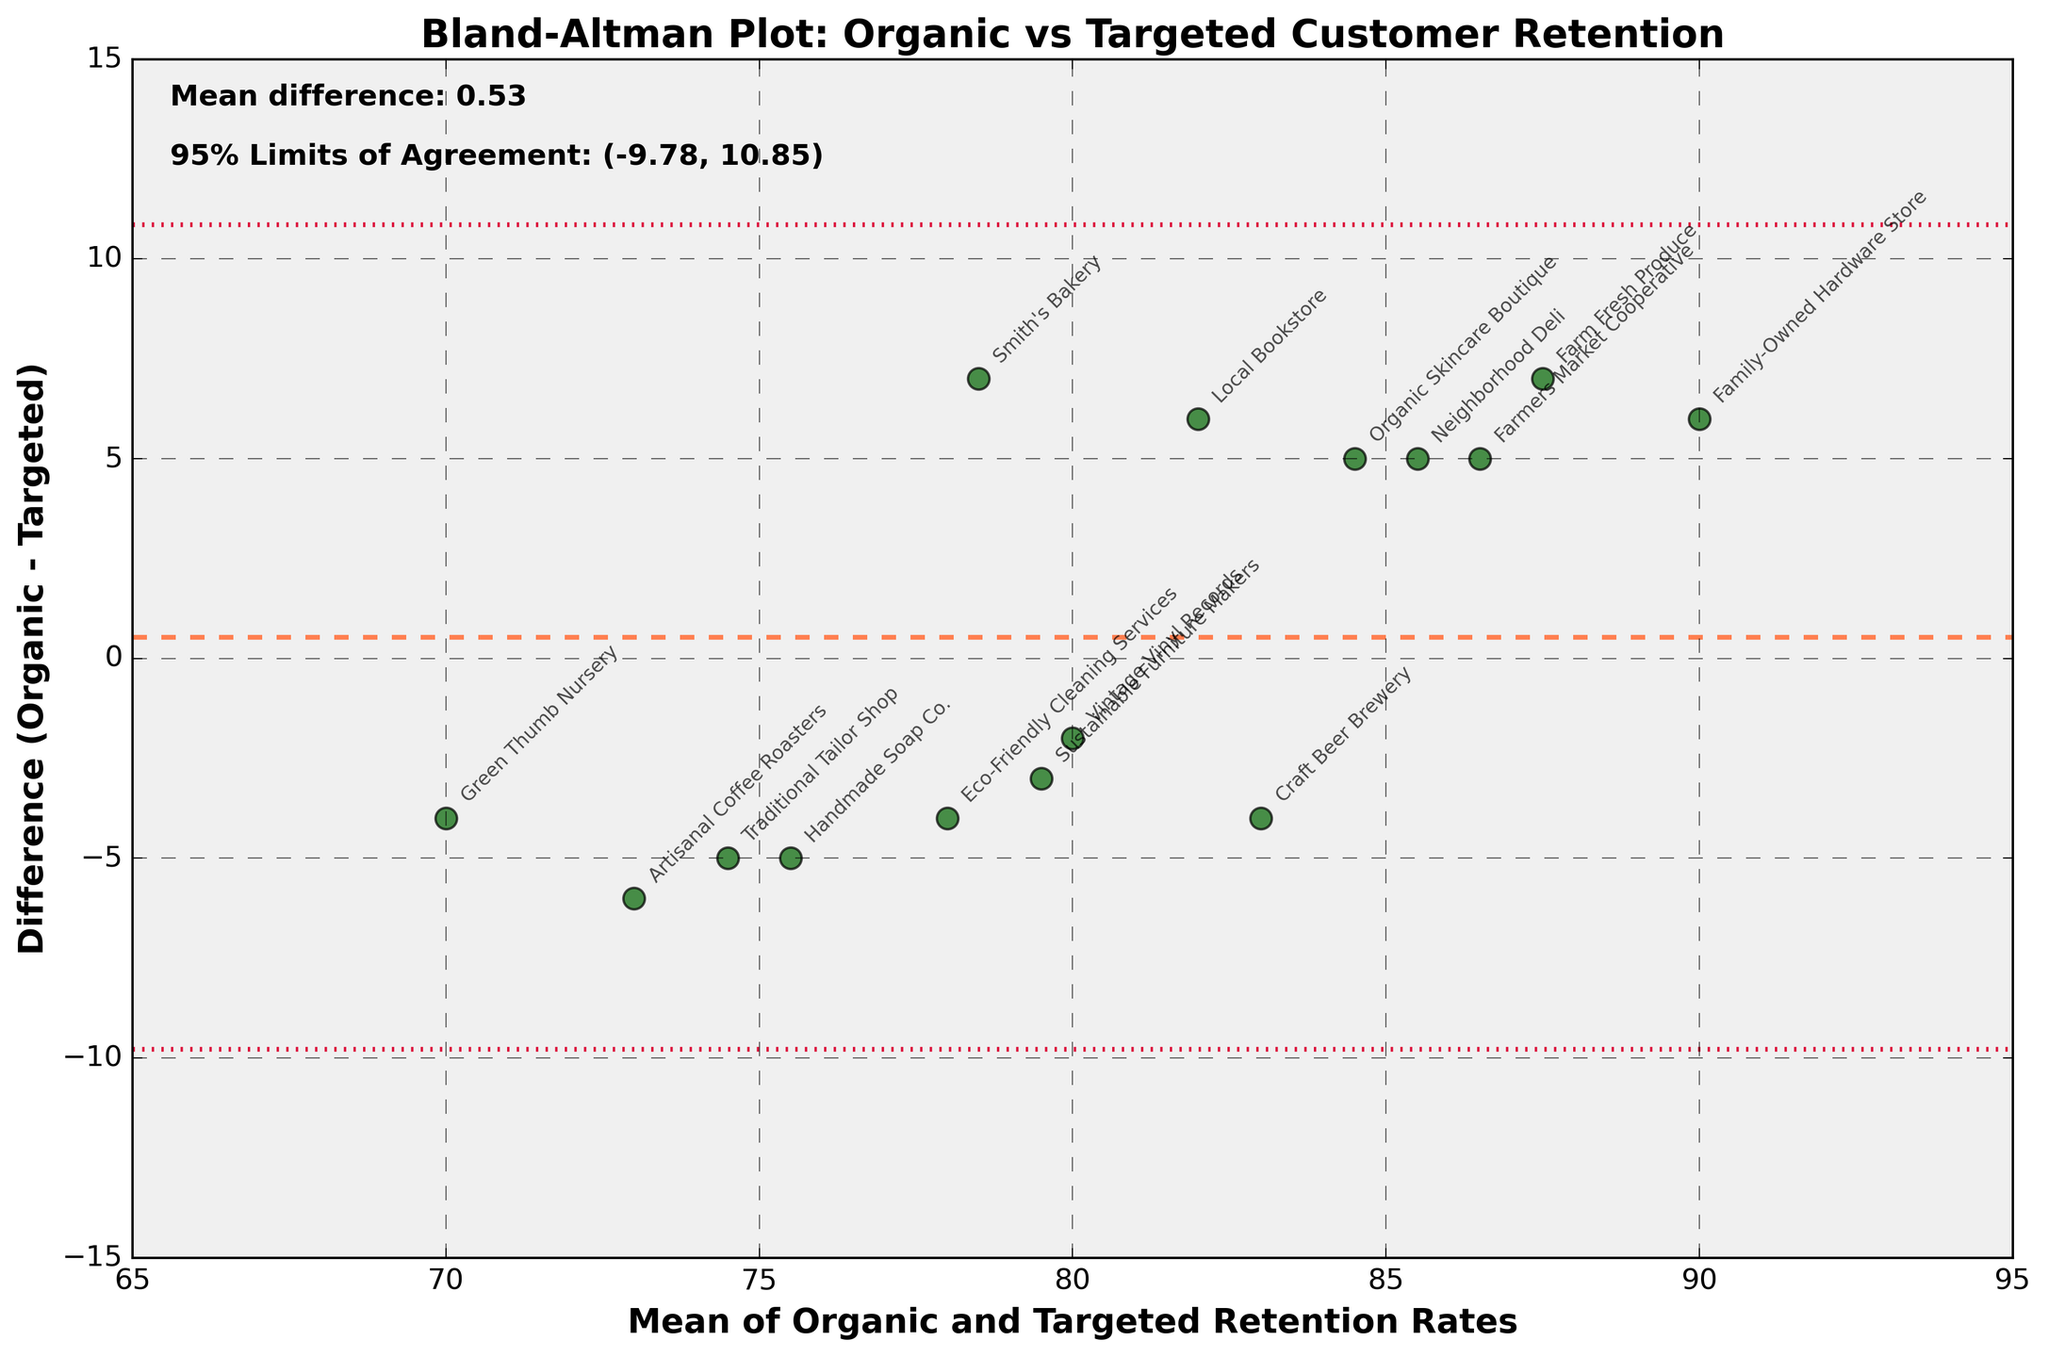What's the title of the figure? The title of the figure is displayed at the top center part of the plot. This is easy to identify as it is in a larger and bold font compared to the other text.
Answer: Bland-Altman Plot: Organic vs Targeted Customer Retention How many businesses are represented in the figure? The number of businesses can be determined by counting the number of data points or annotated labels on the plot. Each data point represents one business.
Answer: 15 What does the x-axis represent? The x-axis label is clear and states what it represents. This can be seen in the bottom part of the plot.
Answer: Mean of Organic and Targeted Retention Rates What is the mean difference of retention rates between the two strategies? The mean difference is often explicitly noted in the plot. It can be found as text or as the value of a central horizontal line between the limits of agreement.
Answer: 4.00 What are the 95% limits of agreement? The 95% limits of agreement are usually displayed on the plot and represent the range within which 95% of differences are expected to fall. These are often marked with dotted lines parallel to the mean difference line.
Answer: -2.14, 10.14 Which business shows the highest positive difference (Organic - Targeted)? Identify the point that is farthest above the mean difference line. The annotation next to this point indicates the business name.
Answer: Family-Owned Hardware Store Are most differences positive or negative? Observe the scatterplot and count or estimate the number of points above and below the horizontal line representing the mean difference. Most points being above indicates more positive differences and vice versa.
Answer: Positive What's the range of the mean of retention rates shown in the figure? The limits of the x-axis give the range of the mean retention rates. You can observe the minimum and maximum values on the x-axis.
Answer: Approximately 70 to 90 Which business shows the smallest difference (closest to zero) in retention rates? Look for the data point nearest to the mean difference line. The annotation closest to this point gives the business name.
Answer: Vintage Vinyl Records What is the mean customer retention rate of Smith's Bakery? Identify Smith's Bakery on the plot and locate its corresponding point on both axes. The x-axis value gives the mean rate.
Answer: 78.5 